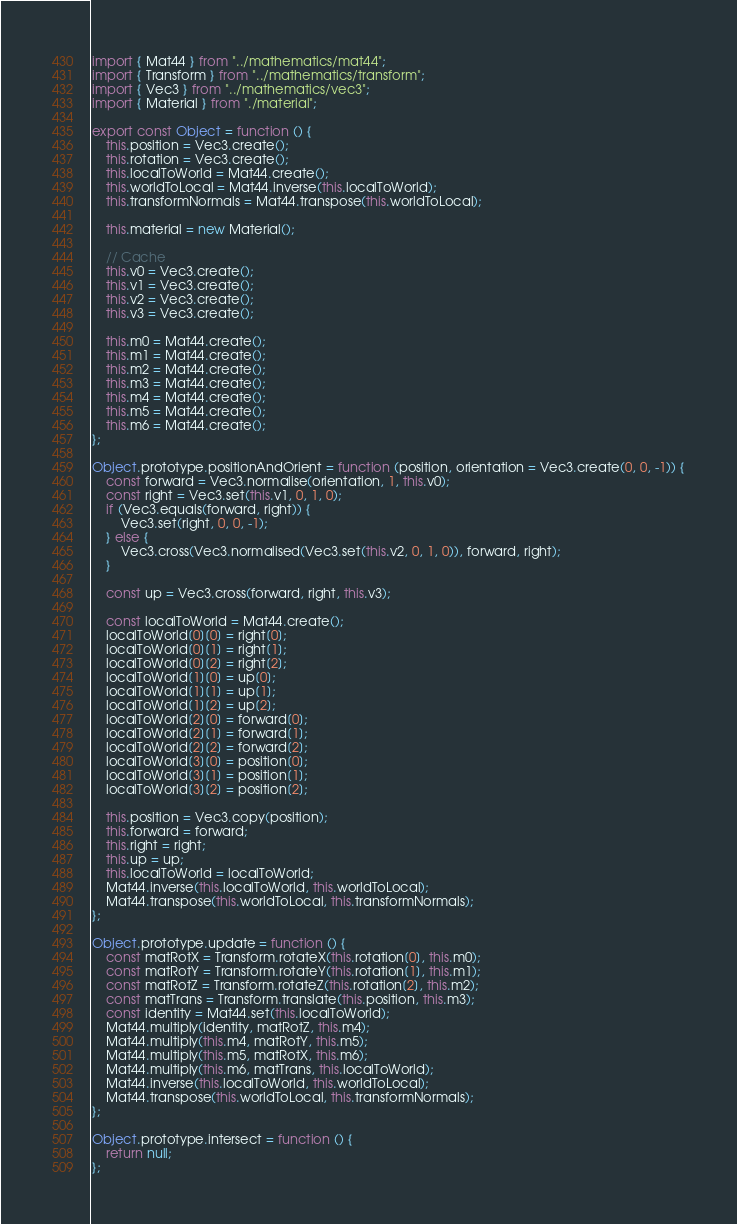<code> <loc_0><loc_0><loc_500><loc_500><_JavaScript_>import { Mat44 } from "../mathematics/mat44";
import { Transform } from "../mathematics/transform";
import { Vec3 } from "../mathematics/vec3";
import { Material } from "./material";

export const Object = function () {
    this.position = Vec3.create();
    this.rotation = Vec3.create();
    this.localToWorld = Mat44.create();
    this.worldToLocal = Mat44.inverse(this.localToWorld);
    this.transformNormals = Mat44.transpose(this.worldToLocal);

    this.material = new Material();

    // Cache
    this.v0 = Vec3.create();
    this.v1 = Vec3.create();
    this.v2 = Vec3.create();
    this.v3 = Vec3.create();

    this.m0 = Mat44.create();
    this.m1 = Mat44.create();
    this.m2 = Mat44.create();
    this.m3 = Mat44.create();
    this.m4 = Mat44.create();
    this.m5 = Mat44.create();
    this.m6 = Mat44.create();
};

Object.prototype.positionAndOrient = function (position, orientation = Vec3.create(0, 0, -1)) {
    const forward = Vec3.normalise(orientation, 1, this.v0);
    const right = Vec3.set(this.v1, 0, 1, 0);
    if (Vec3.equals(forward, right)) {
        Vec3.set(right, 0, 0, -1);
    } else {
        Vec3.cross(Vec3.normalised(Vec3.set(this.v2, 0, 1, 0)), forward, right);
    }

    const up = Vec3.cross(forward, right, this.v3);

    const localToWorld = Mat44.create();
    localToWorld[0][0] = right[0];
    localToWorld[0][1] = right[1];
    localToWorld[0][2] = right[2];
    localToWorld[1][0] = up[0];
    localToWorld[1][1] = up[1];
    localToWorld[1][2] = up[2];
    localToWorld[2][0] = forward[0];
    localToWorld[2][1] = forward[1];
    localToWorld[2][2] = forward[2];
    localToWorld[3][0] = position[0];
    localToWorld[3][1] = position[1];
    localToWorld[3][2] = position[2];

    this.position = Vec3.copy(position);
    this.forward = forward;
    this.right = right;
    this.up = up;
    this.localToWorld = localToWorld;
    Mat44.inverse(this.localToWorld, this.worldToLocal);
    Mat44.transpose(this.worldToLocal, this.transformNormals);
};

Object.prototype.update = function () {
    const matRotX = Transform.rotateX(this.rotation[0], this.m0);
    const matRotY = Transform.rotateY(this.rotation[1], this.m1);
    const matRotZ = Transform.rotateZ(this.rotation[2], this.m2);
    const matTrans = Transform.translate(this.position, this.m3);
    const identity = Mat44.set(this.localToWorld);
    Mat44.multiply(identity, matRotZ, this.m4);
    Mat44.multiply(this.m4, matRotY, this.m5);
    Mat44.multiply(this.m5, matRotX, this.m6);
    Mat44.multiply(this.m6, matTrans, this.localToWorld);
    Mat44.inverse(this.localToWorld, this.worldToLocal);
    Mat44.transpose(this.worldToLocal, this.transformNormals);
};

Object.prototype.intersect = function () {
    return null;
};
</code> 